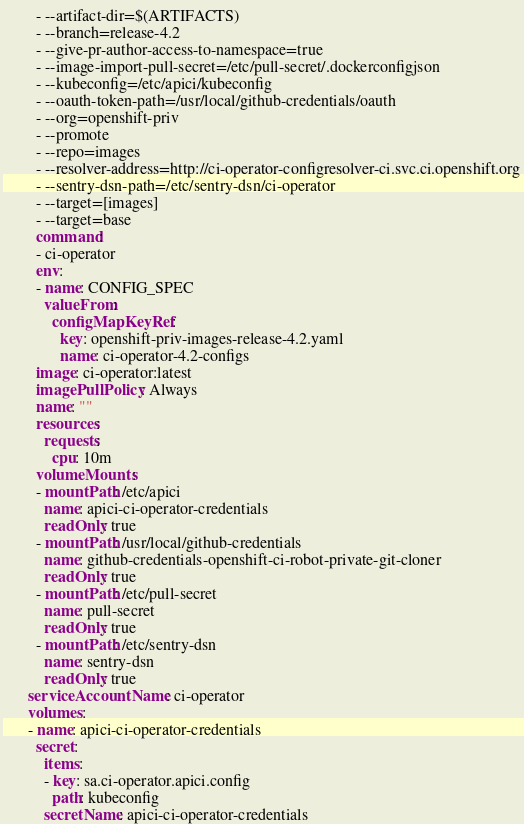<code> <loc_0><loc_0><loc_500><loc_500><_YAML_>        - --artifact-dir=$(ARTIFACTS)
        - --branch=release-4.2
        - --give-pr-author-access-to-namespace=true
        - --image-import-pull-secret=/etc/pull-secret/.dockerconfigjson
        - --kubeconfig=/etc/apici/kubeconfig
        - --oauth-token-path=/usr/local/github-credentials/oauth
        - --org=openshift-priv
        - --promote
        - --repo=images
        - --resolver-address=http://ci-operator-configresolver-ci.svc.ci.openshift.org
        - --sentry-dsn-path=/etc/sentry-dsn/ci-operator
        - --target=[images]
        - --target=base
        command:
        - ci-operator
        env:
        - name: CONFIG_SPEC
          valueFrom:
            configMapKeyRef:
              key: openshift-priv-images-release-4.2.yaml
              name: ci-operator-4.2-configs
        image: ci-operator:latest
        imagePullPolicy: Always
        name: ""
        resources:
          requests:
            cpu: 10m
        volumeMounts:
        - mountPath: /etc/apici
          name: apici-ci-operator-credentials
          readOnly: true
        - mountPath: /usr/local/github-credentials
          name: github-credentials-openshift-ci-robot-private-git-cloner
          readOnly: true
        - mountPath: /etc/pull-secret
          name: pull-secret
          readOnly: true
        - mountPath: /etc/sentry-dsn
          name: sentry-dsn
          readOnly: true
      serviceAccountName: ci-operator
      volumes:
      - name: apici-ci-operator-credentials
        secret:
          items:
          - key: sa.ci-operator.apici.config
            path: kubeconfig
          secretName: apici-ci-operator-credentials</code> 